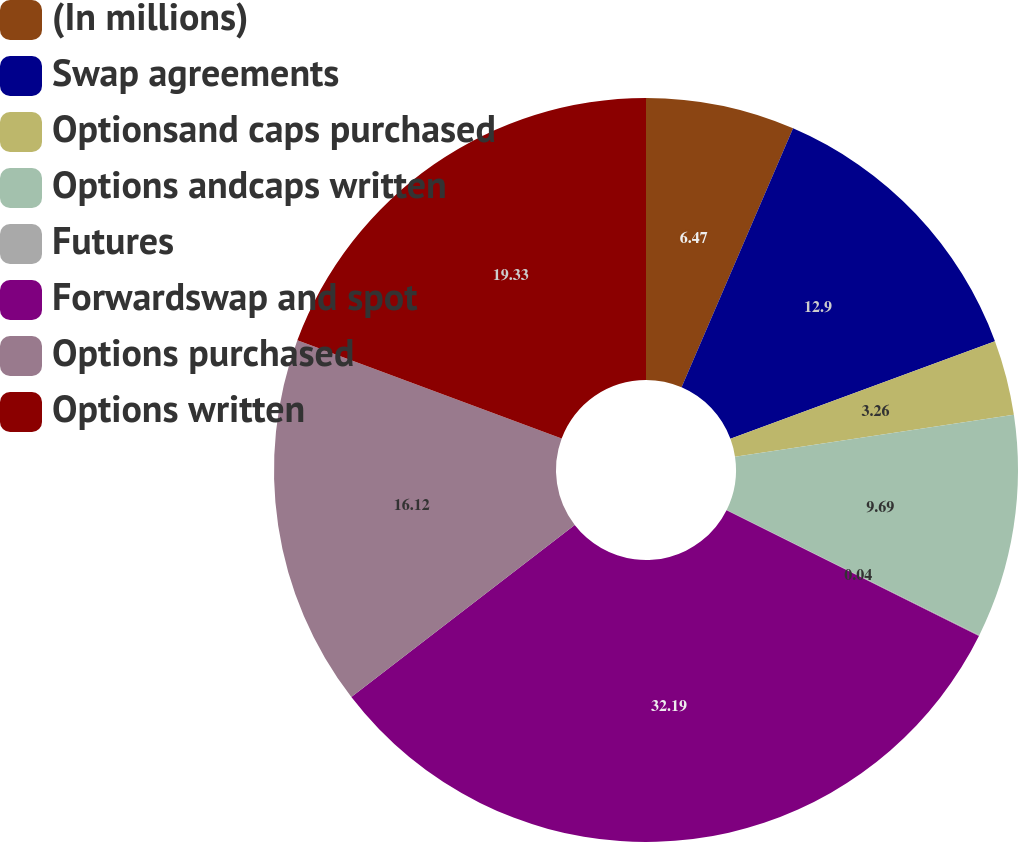Convert chart. <chart><loc_0><loc_0><loc_500><loc_500><pie_chart><fcel>(In millions)<fcel>Swap agreements<fcel>Optionsand caps purchased<fcel>Options andcaps written<fcel>Futures<fcel>Forwardswap and spot<fcel>Options purchased<fcel>Options written<nl><fcel>6.47%<fcel>12.9%<fcel>3.26%<fcel>9.69%<fcel>0.04%<fcel>32.19%<fcel>16.12%<fcel>19.33%<nl></chart> 